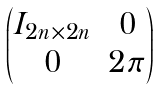<formula> <loc_0><loc_0><loc_500><loc_500>\begin{pmatrix} I _ { 2 n \times 2 n } & 0 \\ 0 & 2 \pi \end{pmatrix}</formula> 